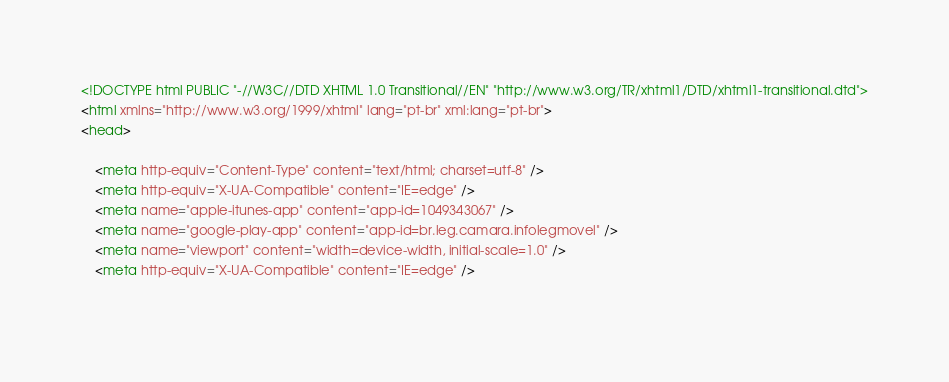<code> <loc_0><loc_0><loc_500><loc_500><_HTML_>




<!DOCTYPE html PUBLIC "-//W3C//DTD XHTML 1.0 Transitional//EN" "http://www.w3.org/TR/xhtml1/DTD/xhtml1-transitional.dtd">
<html xmlns="http://www.w3.org/1999/xhtml" lang="pt-br" xml:lang="pt-br">
<head>
	    
    <meta http-equiv="Content-Type" content="text/html; charset=utf-8" />
    <meta http-equiv="X-UA-Compatible" content="IE=edge" />
    <meta name="apple-itunes-app" content="app-id=1049343067" />
    <meta name="google-play-app" content="app-id=br.leg.camara.infolegmovel" />
    <meta name="viewport" content="width=device-width, initial-scale=1.0" />
	<meta http-equiv="X-UA-Compatible" content="IE=edge" /> 
    </code> 